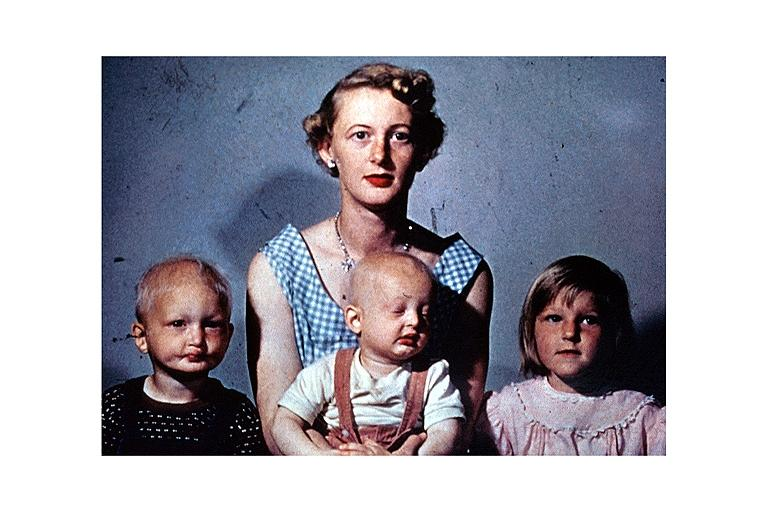what is present?
Answer the question using a single word or phrase. Oral 